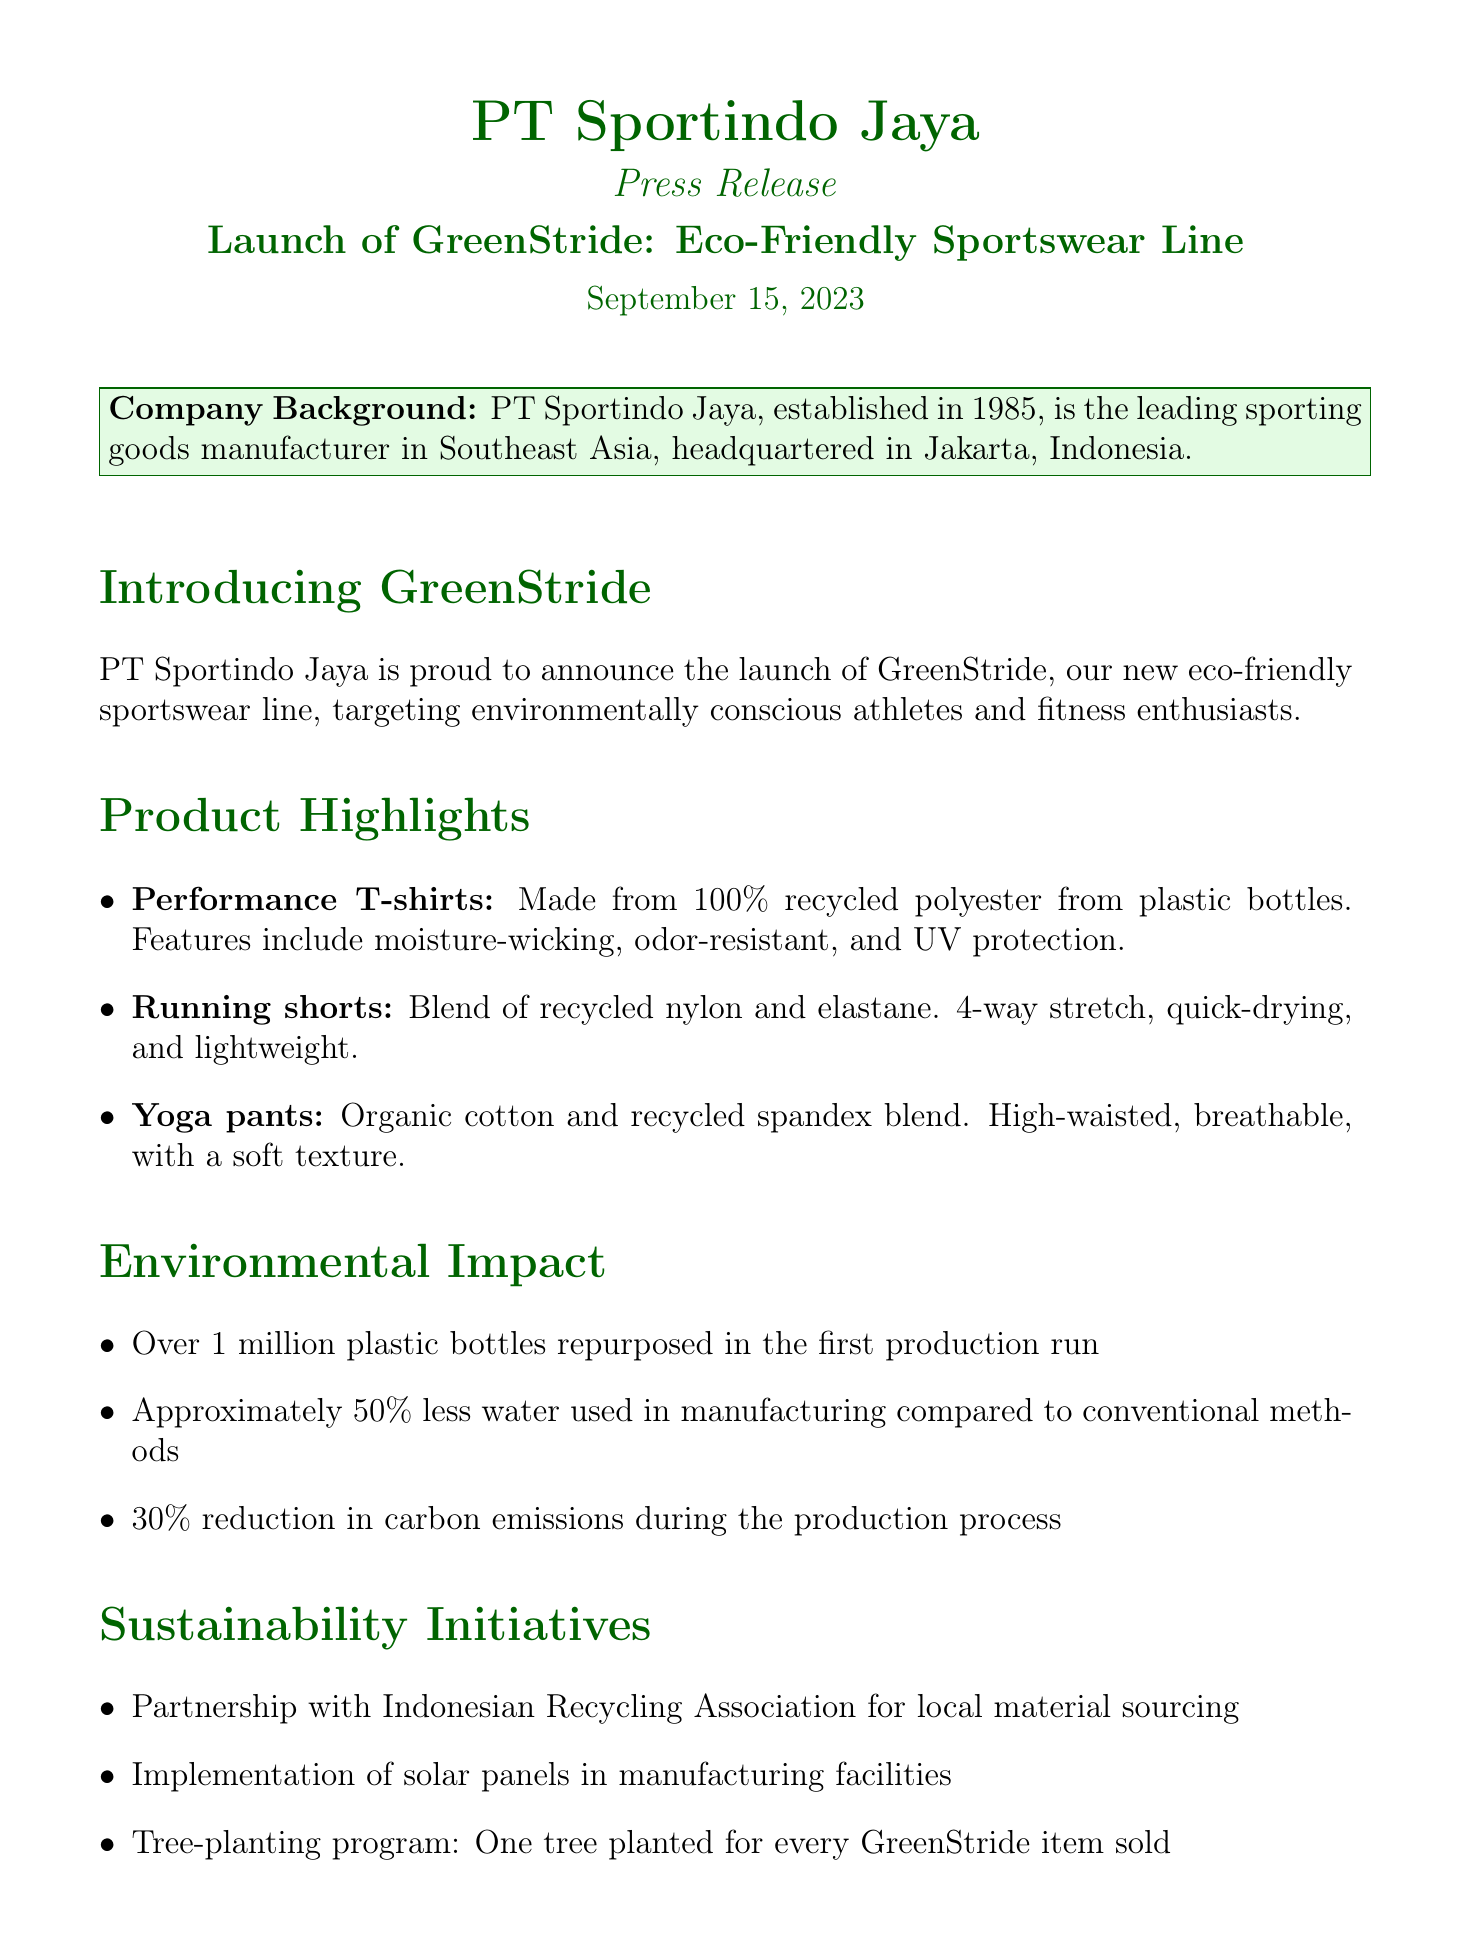What is the name of the eco-friendly sportswear line? The document states the name of the eco-friendly sportswear line, which is GreenStride.
Answer: GreenStride When was the GreenStride line launched? The launch date is explicitly mentioned in the document as September 15, 2023.
Answer: September 15, 2023 What material is used in the performance T-shirts? The document specifies that the Performance T-shirts are made from 100% recycled polyester from plastic bottles.
Answer: 100% recycled polyester from plastic bottles How many plastic bottles were recycled in the first production run? The document indicates that over 1 million plastic bottles were repurposed.
Answer: Over 1 million What initiative involves planting trees related to purchases? The document mentions a tree-planting program where one tree is planted for every GreenStride item sold.
Answer: One tree planted for every GreenStride item sold Who is the CEO of PT Sportindo Jaya? The CEO's name is provided in the document, which is Budi Santoso.
Answer: Budi Santoso What percent reduction in carbon emissions was achieved during production? The document states there was a 30% reduction in carbon emissions.
Answer: 30% What is the target market for the GreenStride line? The target market specified in the document is environmentally conscious athletes and fitness enthusiasts.
Answer: Environmentally conscious athletes and fitness enthusiasts 